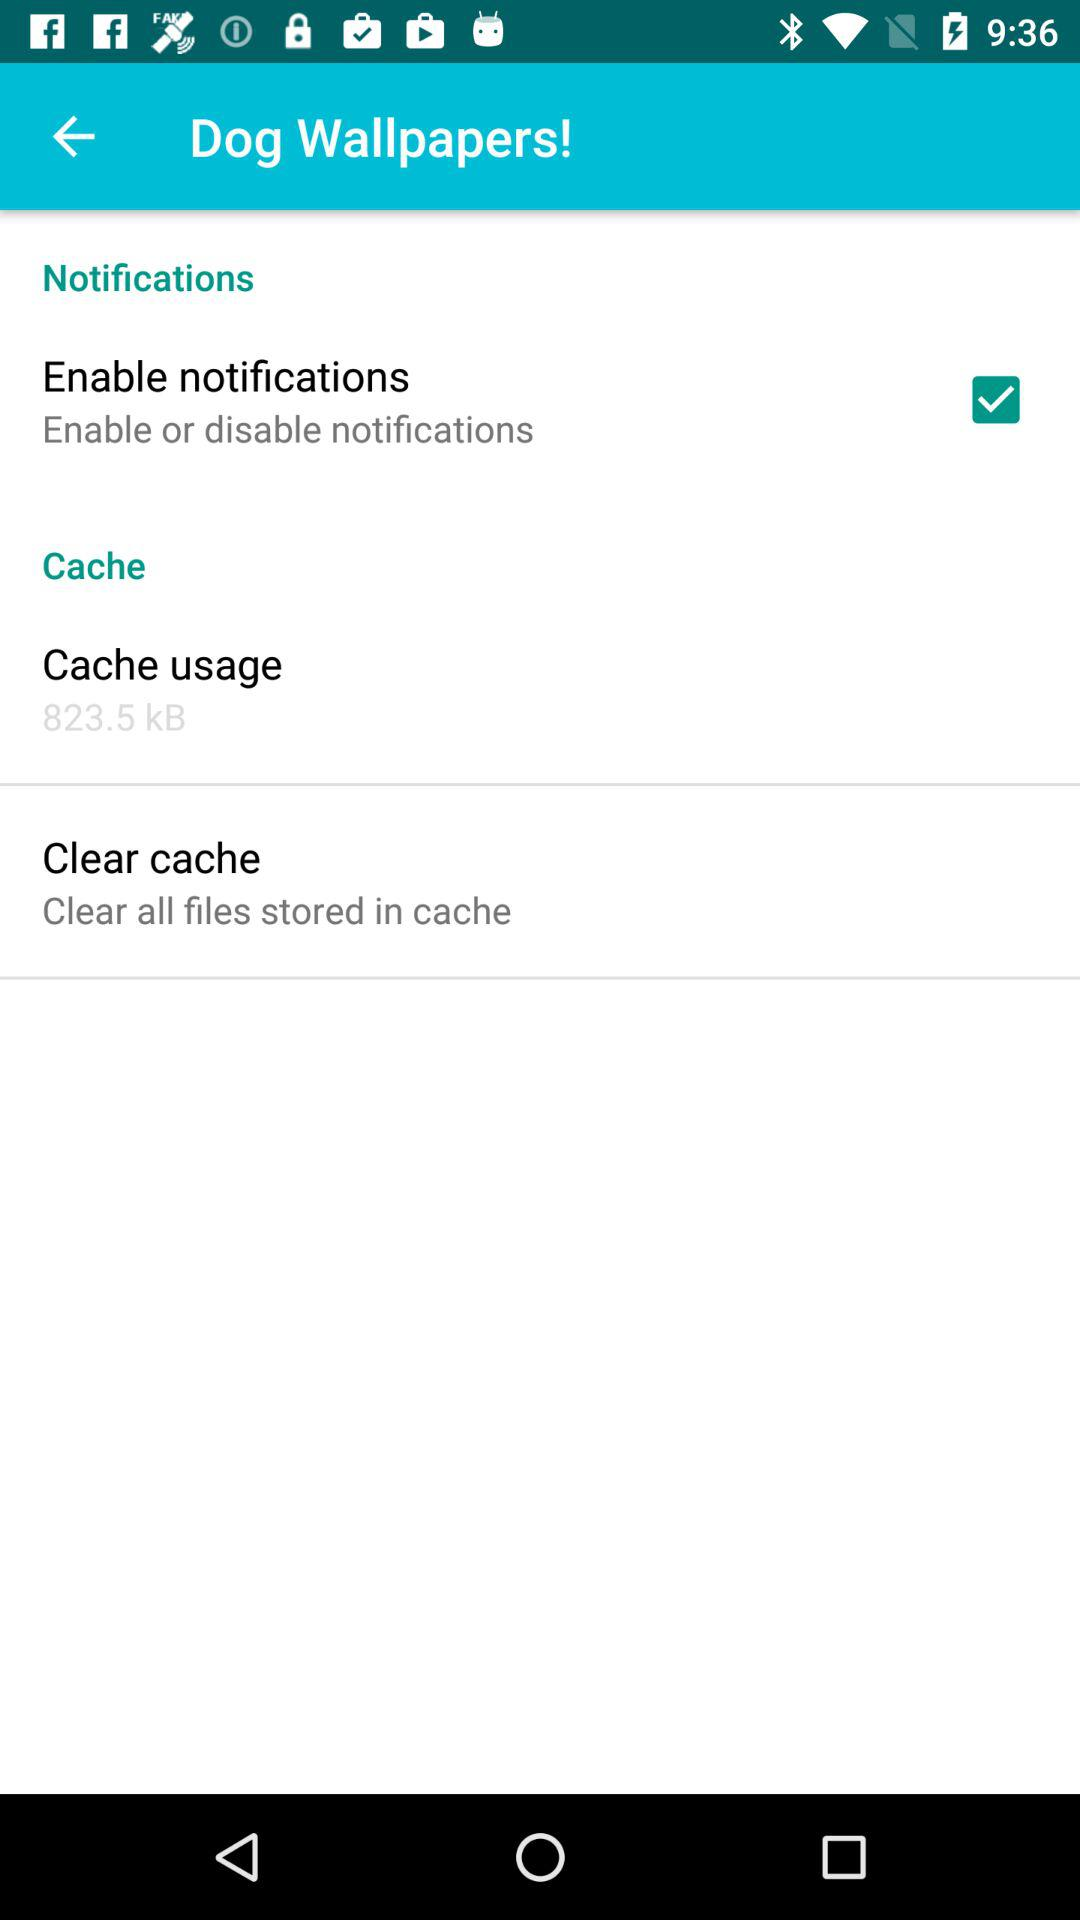Is "Clear cache" on or off?
When the provided information is insufficient, respond with <no answer>. <no answer> 